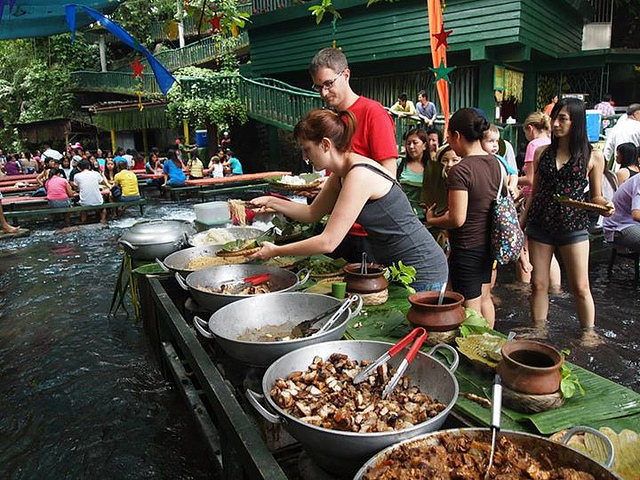<image>What religion are these women? It is not sure what religion these women belong to. It could be anything from Christian, Buddhist, Jewish, Hindu, atheist, or others. What religion are these women? I don't know what religion these women are. They can be Christian, Buddhist, Jewish, atheists, or Hindu. 